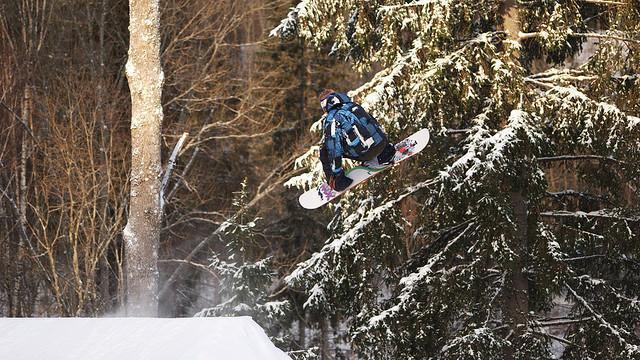How many giraffes are there?
Give a very brief answer. 0. 